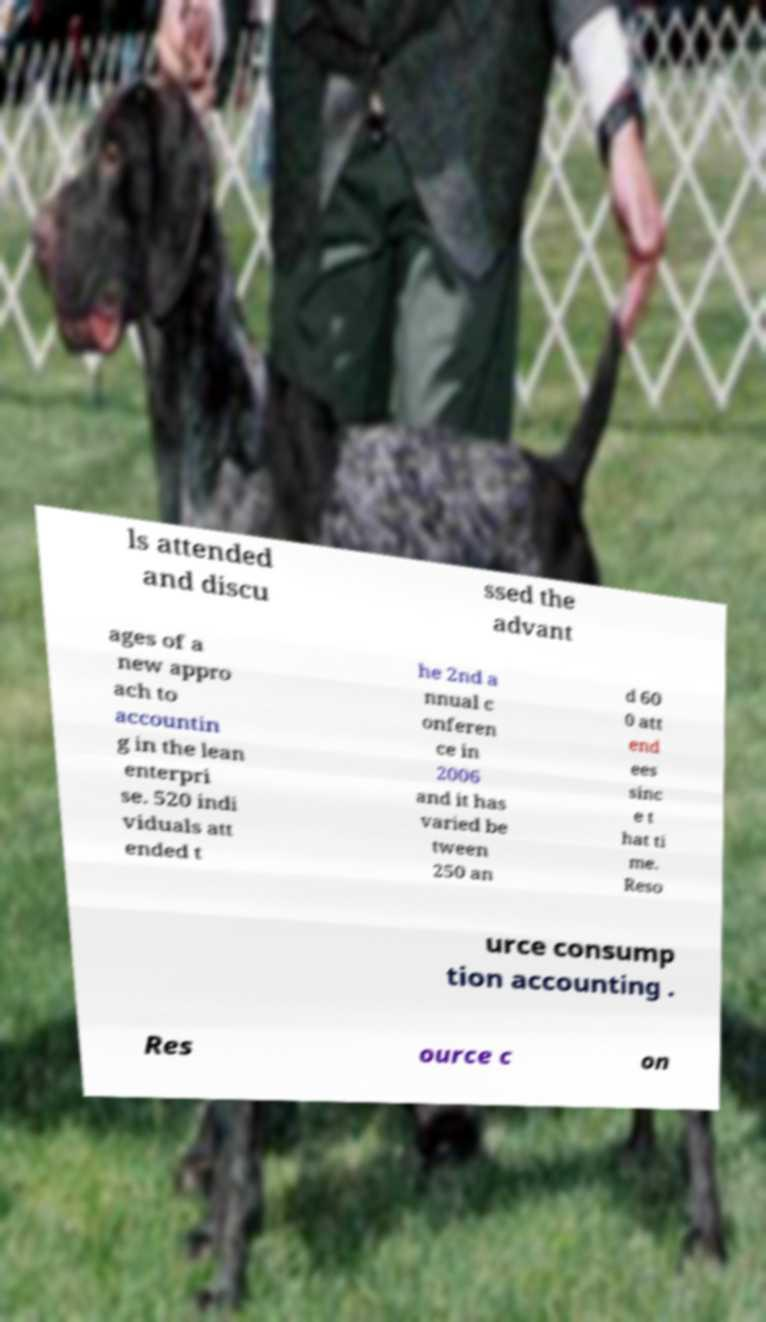There's text embedded in this image that I need extracted. Can you transcribe it verbatim? ls attended and discu ssed the advant ages of a new appro ach to accountin g in the lean enterpri se. 520 indi viduals att ended t he 2nd a nnual c onferen ce in 2006 and it has varied be tween 250 an d 60 0 att end ees sinc e t hat ti me. Reso urce consump tion accounting . Res ource c on 